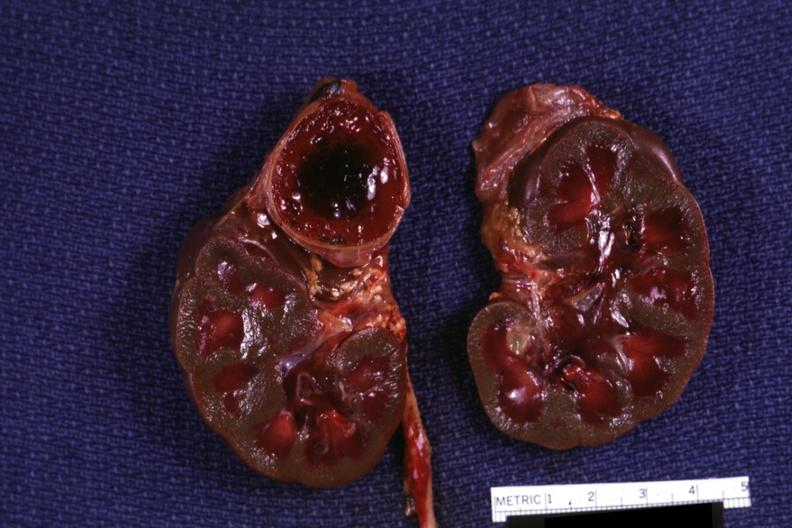do intraductal lesions hemorrhage on one side kidneys are jaundiced?
Answer the question using a single word or phrase. No 